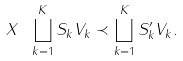<formula> <loc_0><loc_0><loc_500><loc_500>X \ \bigsqcup _ { k = 1 } ^ { K } S _ { k } V _ { k } \prec \bigsqcup _ { k = 1 } ^ { K } S _ { k } ^ { \prime } V _ { k } .</formula> 